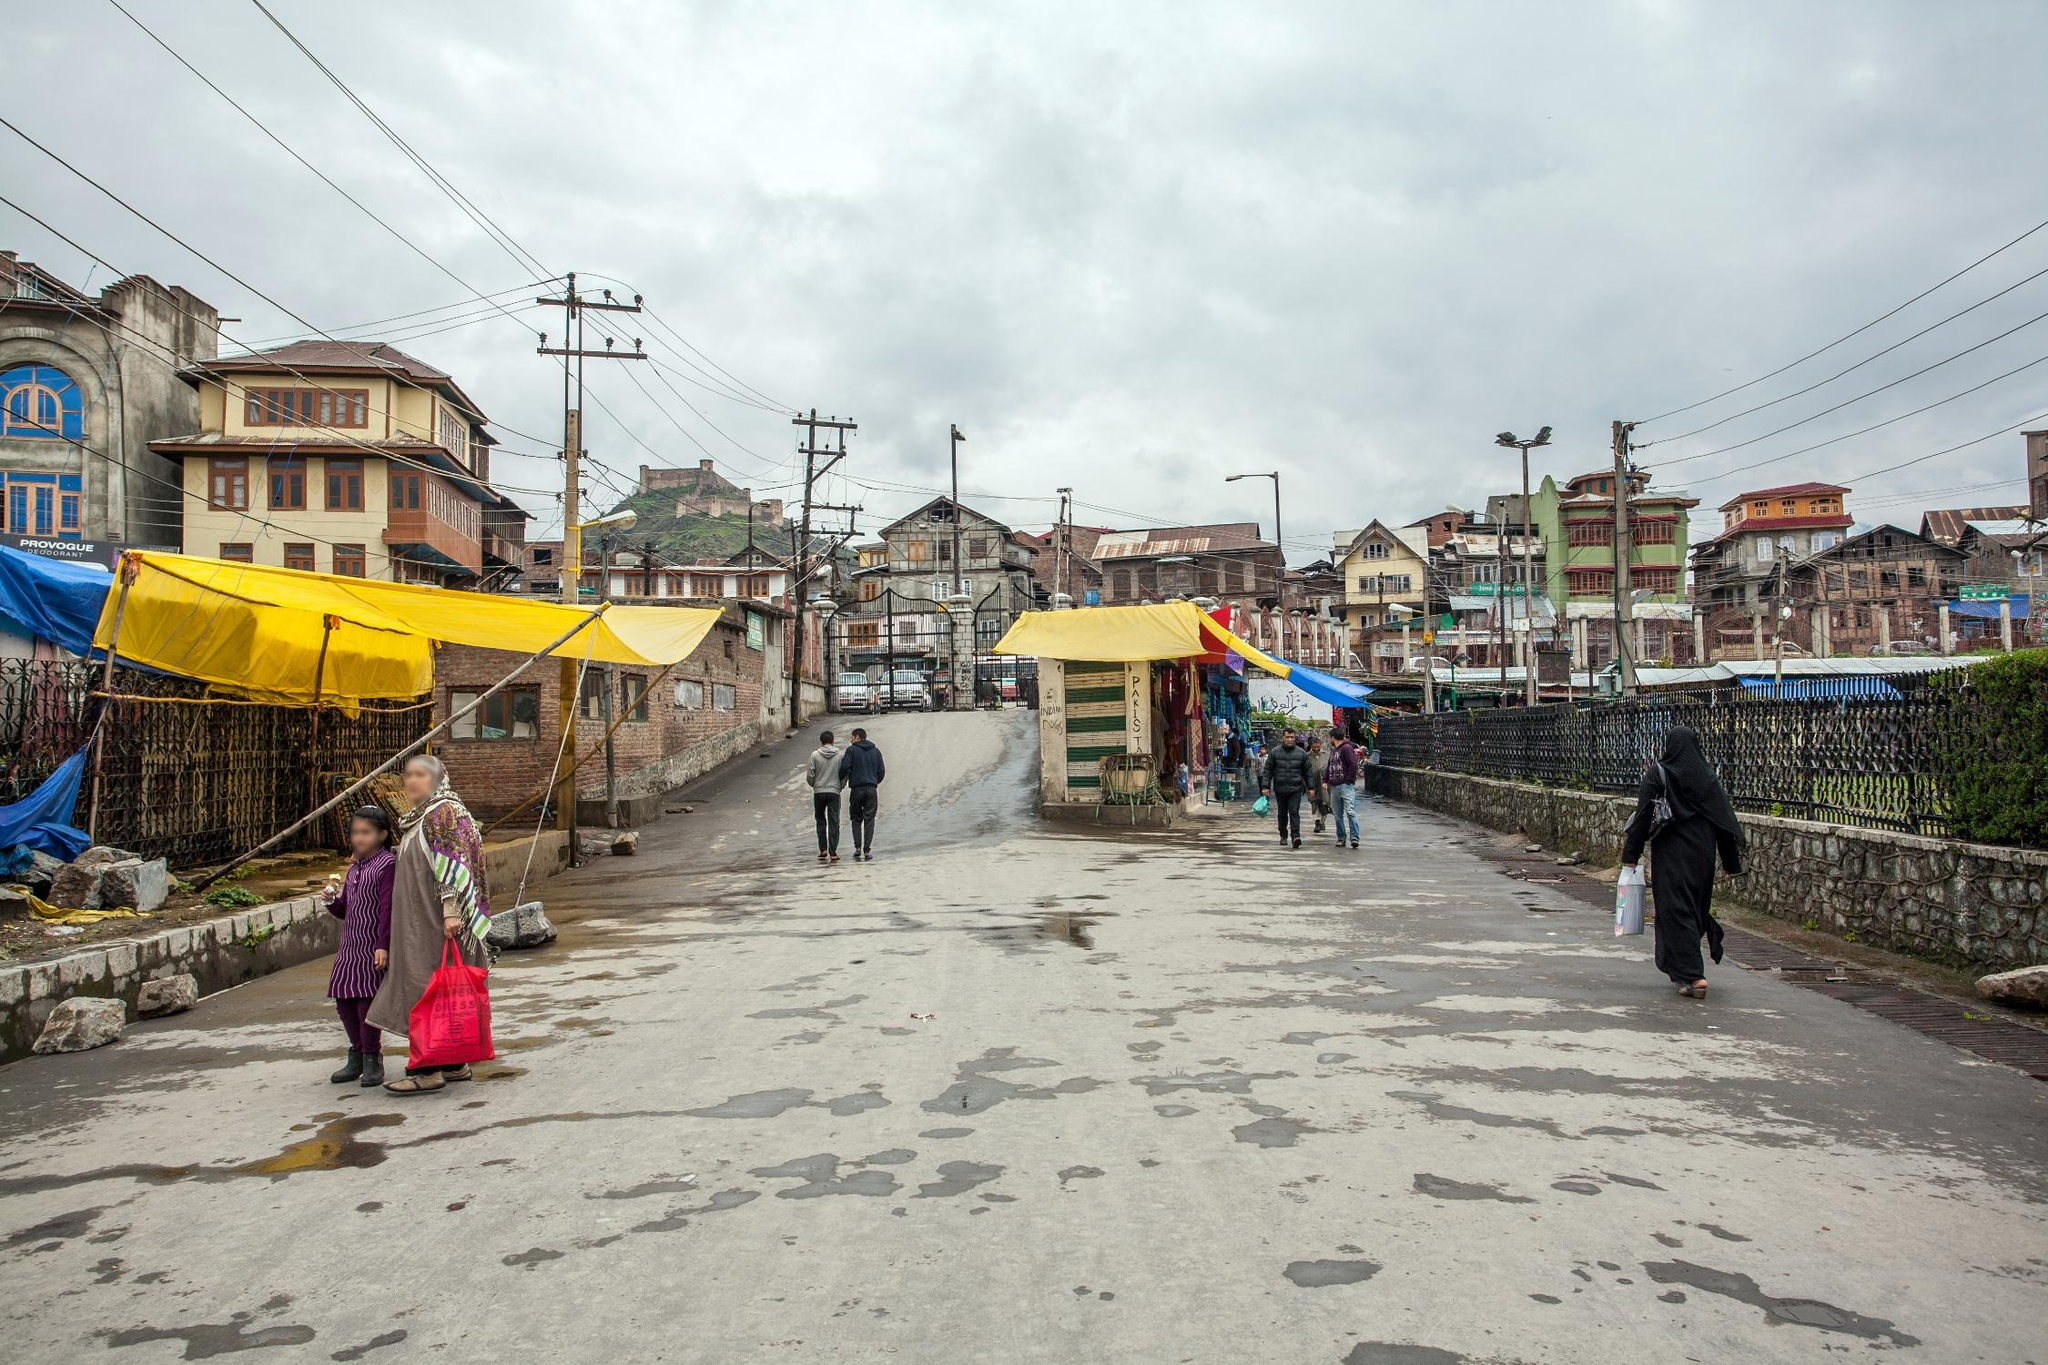What's happening in the scene? The image portrays a typical day on a street in Srinagar, India. The scene is alive with daily activities, as pedestrians navigate around a large puddle in the middle of the road, the result of recent rainfall. Colorful buildings and market tents add vibrancy to the otherwise gray day. The backdrop of grey clouds hanging low in the sky sets a somber tone, yet does not deter the animated bustling of the street's occupants. This snapshot eloquently captures the resilience and spirited daily life of the local populace against the moody weather. 